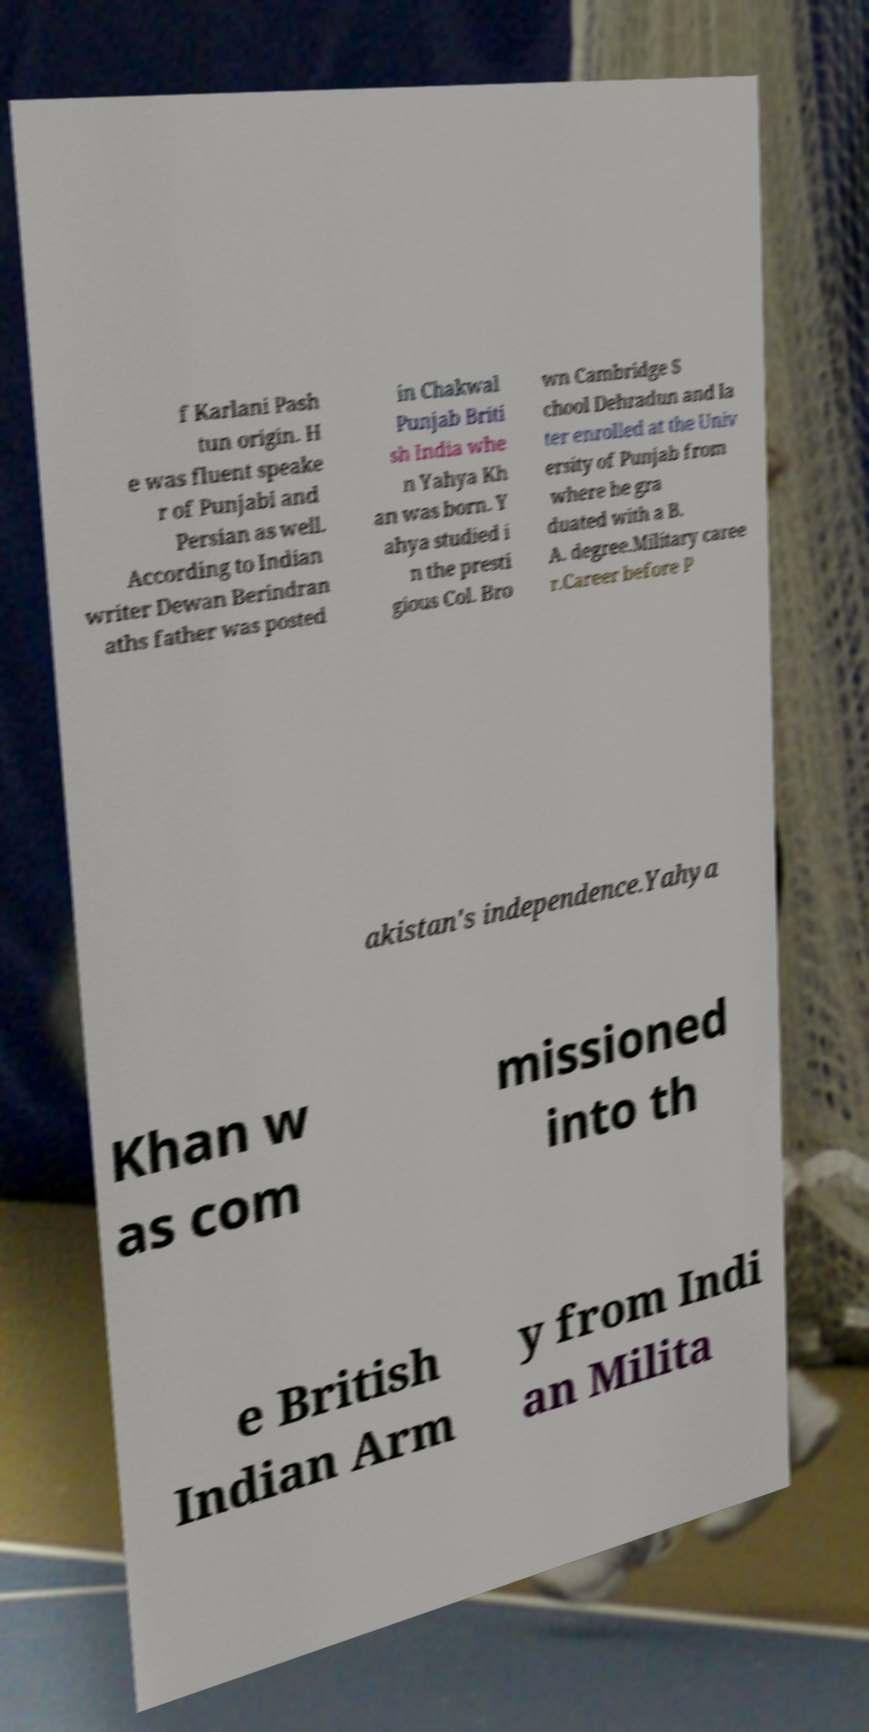Please read and relay the text visible in this image. What does it say? f Karlani Pash tun origin. H e was fluent speake r of Punjabi and Persian as well. According to Indian writer Dewan Berindran aths father was posted in Chakwal Punjab Briti sh India whe n Yahya Kh an was born. Y ahya studied i n the presti gious Col. Bro wn Cambridge S chool Dehradun and la ter enrolled at the Univ ersity of Punjab from where he gra duated with a B. A. degree.Military caree r.Career before P akistan's independence.Yahya Khan w as com missioned into th e British Indian Arm y from Indi an Milita 